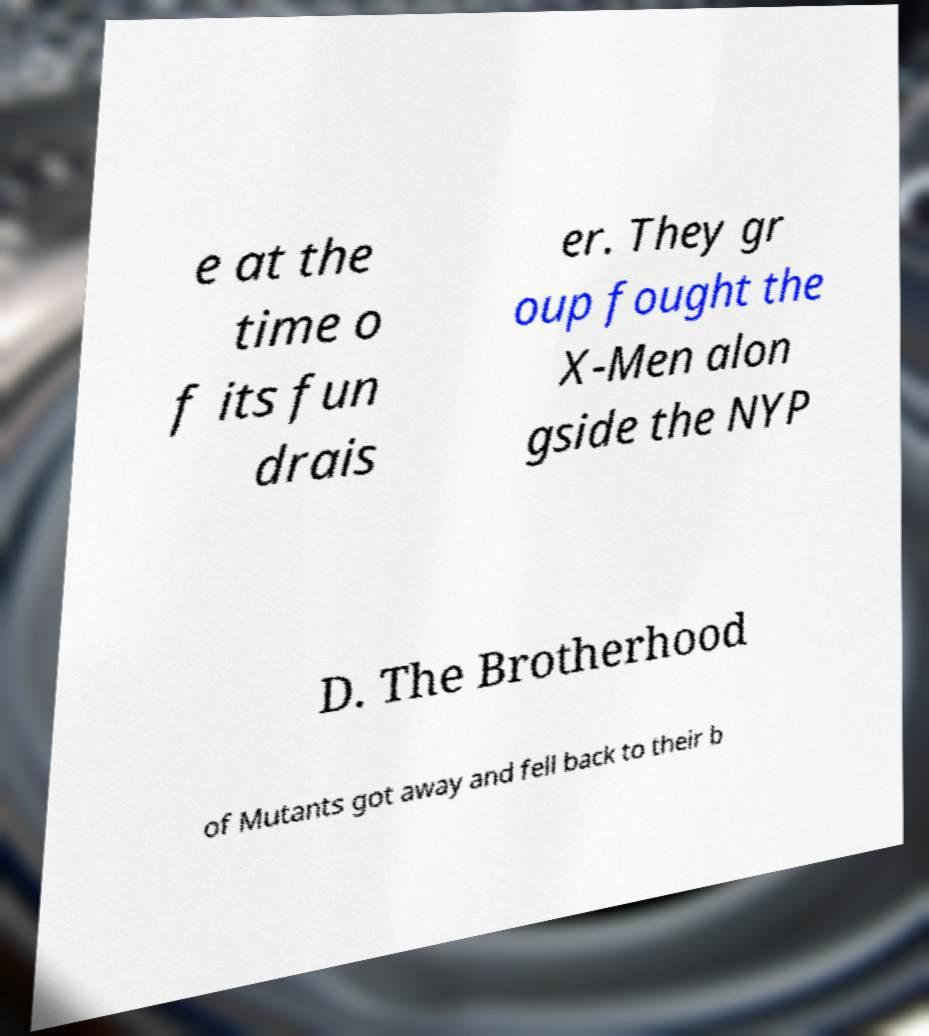Can you read and provide the text displayed in the image?This photo seems to have some interesting text. Can you extract and type it out for me? e at the time o f its fun drais er. They gr oup fought the X-Men alon gside the NYP D. The Brotherhood of Mutants got away and fell back to their b 